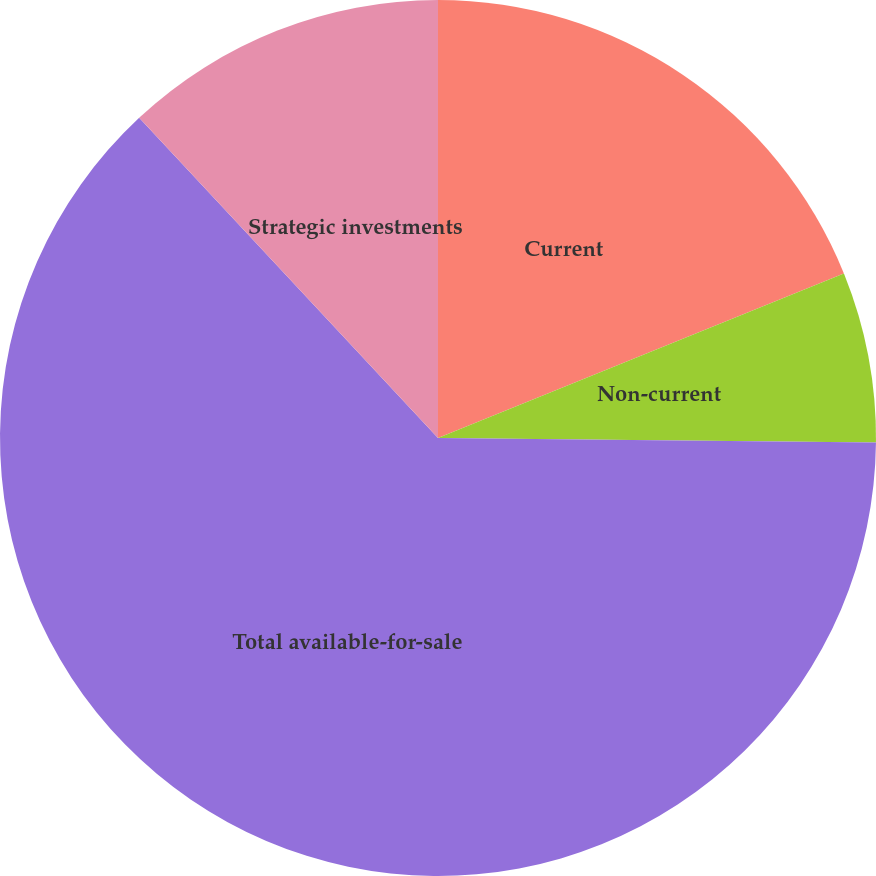Convert chart. <chart><loc_0><loc_0><loc_500><loc_500><pie_chart><fcel>Current<fcel>Non-current<fcel>Total available-for-sale<fcel>Strategic investments<nl><fcel>18.87%<fcel>6.29%<fcel>62.89%<fcel>11.95%<nl></chart> 